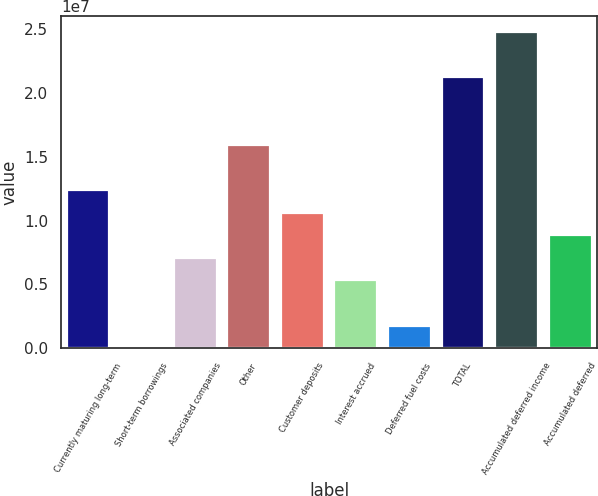Convert chart. <chart><loc_0><loc_0><loc_500><loc_500><bar_chart><fcel>Currently maturing long-term<fcel>Short-term borrowings<fcel>Associated companies<fcel>Other<fcel>Customer deposits<fcel>Interest accrued<fcel>Deferred fuel costs<fcel>TOTAL<fcel>Accumulated deferred income<fcel>Accumulated deferred<nl><fcel>1.2392e+07<fcel>3794<fcel>7.08278e+06<fcel>1.59315e+07<fcel>1.06223e+07<fcel>5.31304e+06<fcel>1.77354e+06<fcel>2.12408e+07<fcel>2.47803e+07<fcel>8.85253e+06<nl></chart> 